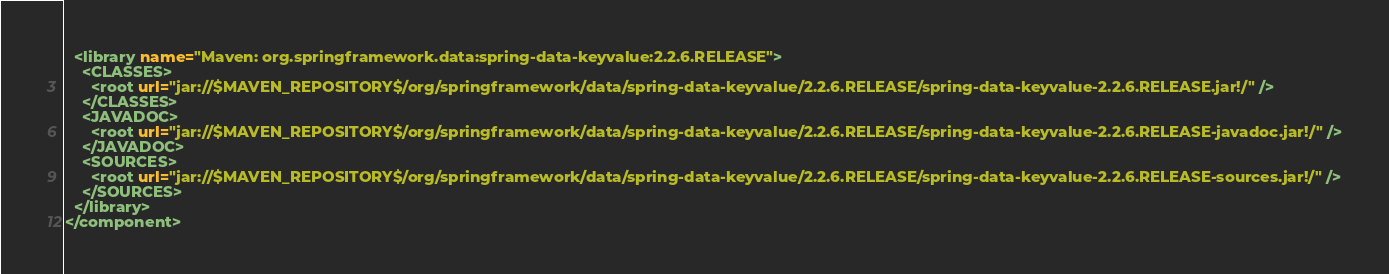<code> <loc_0><loc_0><loc_500><loc_500><_XML_>  <library name="Maven: org.springframework.data:spring-data-keyvalue:2.2.6.RELEASE">
    <CLASSES>
      <root url="jar://$MAVEN_REPOSITORY$/org/springframework/data/spring-data-keyvalue/2.2.6.RELEASE/spring-data-keyvalue-2.2.6.RELEASE.jar!/" />
    </CLASSES>
    <JAVADOC>
      <root url="jar://$MAVEN_REPOSITORY$/org/springframework/data/spring-data-keyvalue/2.2.6.RELEASE/spring-data-keyvalue-2.2.6.RELEASE-javadoc.jar!/" />
    </JAVADOC>
    <SOURCES>
      <root url="jar://$MAVEN_REPOSITORY$/org/springframework/data/spring-data-keyvalue/2.2.6.RELEASE/spring-data-keyvalue-2.2.6.RELEASE-sources.jar!/" />
    </SOURCES>
  </library>
</component></code> 